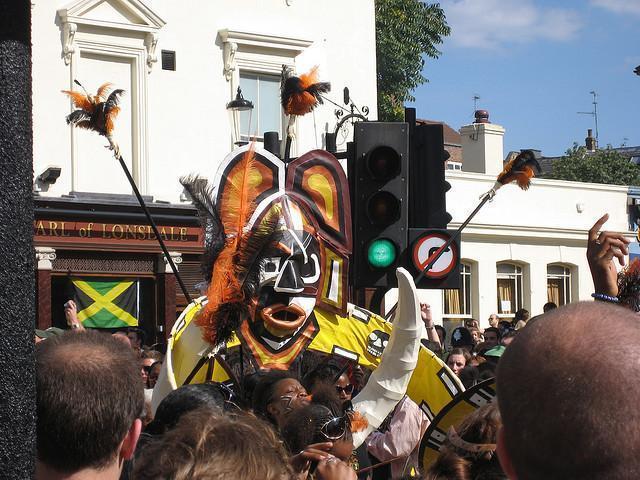What does the color of traffic light in the above picture imply to road users?
Select the correct answer and articulate reasoning with the following format: 'Answer: answer
Rationale: rationale.'
Options: Give way, go, wait, stop. Answer: go.
Rationale: The traffic light is green so it is safe to proceed. 